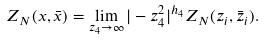<formula> <loc_0><loc_0><loc_500><loc_500>Z _ { N } ( x , \bar { x } ) = \lim _ { z _ { 4 } \to \infty } | - z _ { 4 } ^ { 2 } | ^ { h _ { 4 } } Z _ { N } ( z _ { i } , \bar { z } _ { i } ) .</formula> 